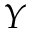<formula> <loc_0><loc_0><loc_500><loc_500>Y</formula> 